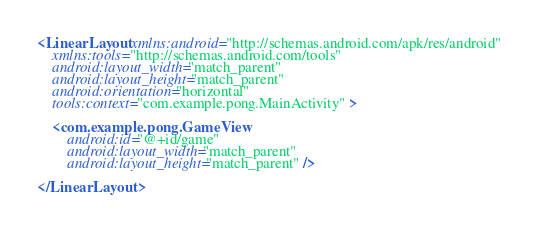<code> <loc_0><loc_0><loc_500><loc_500><_XML_><LinearLayout xmlns:android="http://schemas.android.com/apk/res/android"
    xmlns:tools="http://schemas.android.com/tools"
    android:layout_width="match_parent"
    android:layout_height="match_parent"
    android:orientation="horizontal"
    tools:context="com.example.pong.MainActivity" >

    <com.example.pong.GameView
        android:id="@+id/game"
        android:layout_width="match_parent"
        android:layout_height="match_parent" />

</LinearLayout></code> 